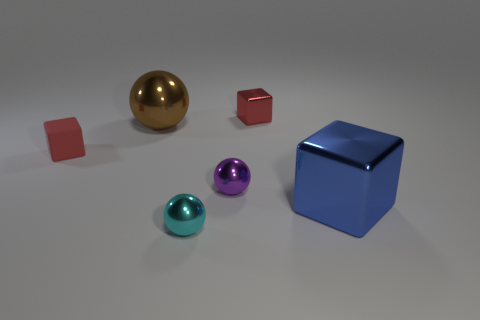Add 1 small purple spheres. How many objects exist? 7 Subtract all small red shiny things. Subtract all small metallic cylinders. How many objects are left? 5 Add 1 big metal cubes. How many big metal cubes are left? 2 Add 3 big brown metallic balls. How many big brown metallic balls exist? 4 Subtract 1 purple spheres. How many objects are left? 5 